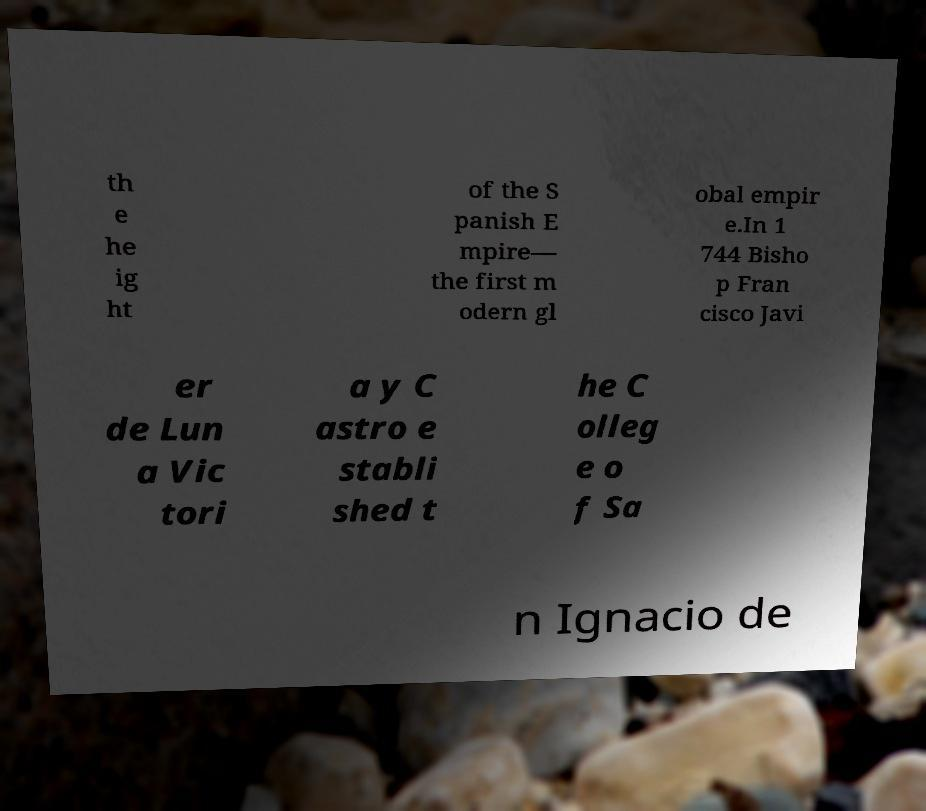I need the written content from this picture converted into text. Can you do that? th e he ig ht of the S panish E mpire— the first m odern gl obal empir e.In 1 744 Bisho p Fran cisco Javi er de Lun a Vic tori a y C astro e stabli shed t he C olleg e o f Sa n Ignacio de 